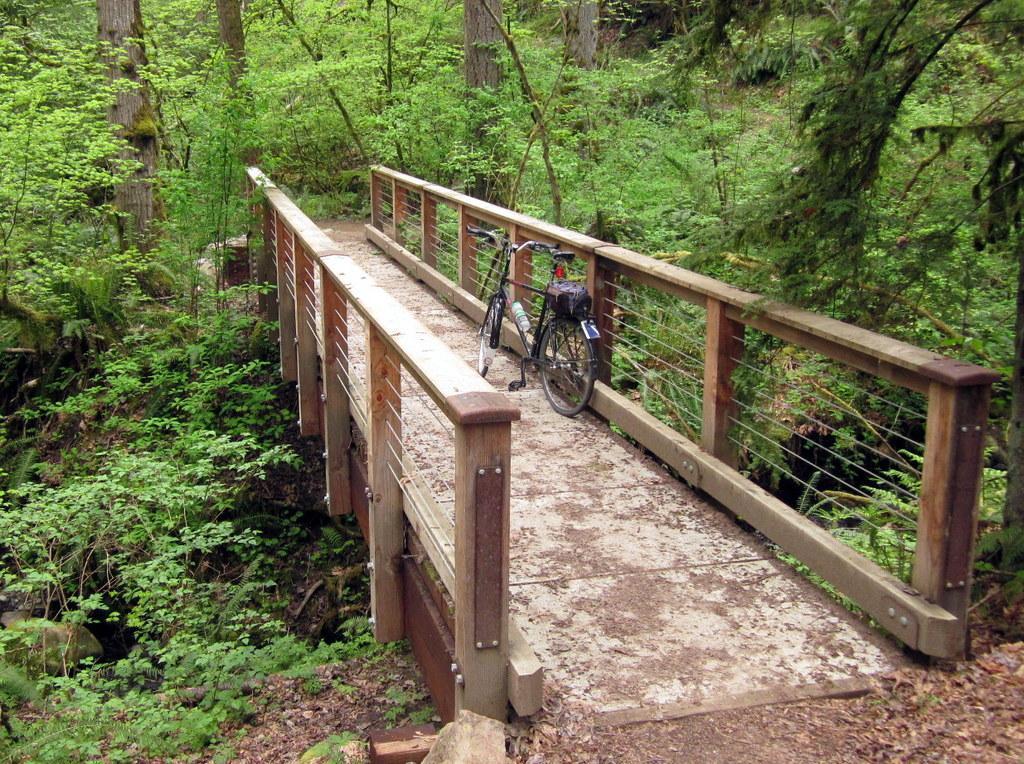How would you summarize this image in a sentence or two? In this picture we can see bicycle is parked on the bridge, beside we can see some trees, plants and dry leaves on the surface. 